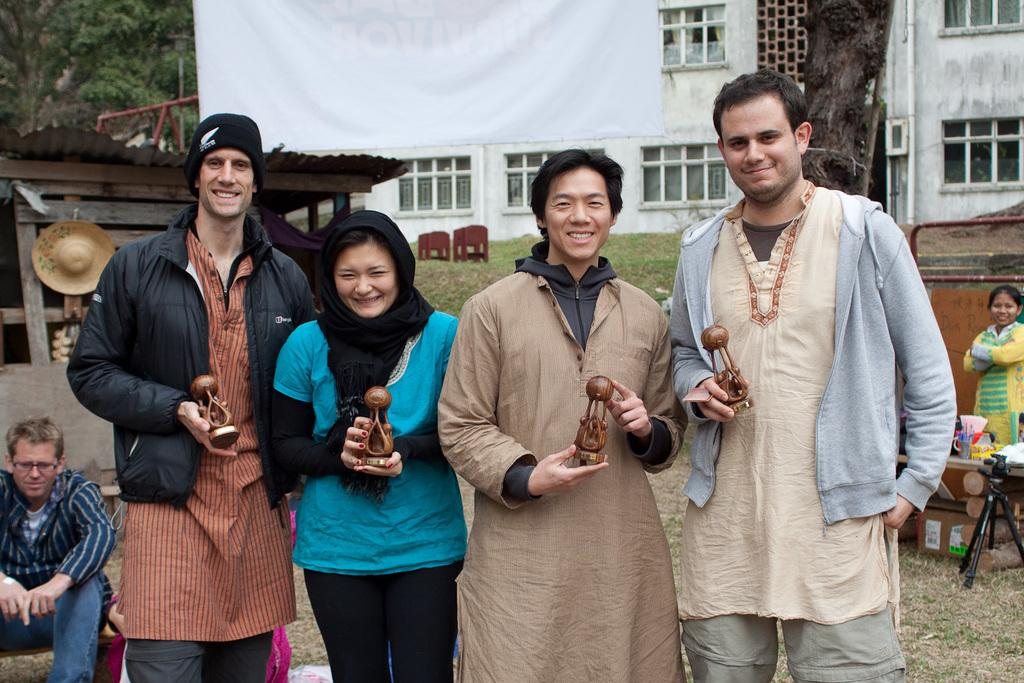How many people are present in the image? There are four persons standing in the image. What are the four persons holding in their hands? Each of the four persons is holding an object in their hands. Can you describe the background of the image? There are people, a building, and trees in the background of the image. What type of screw can be seen in the basket in the image? There is no screw or basket present in the image. Can you describe the feather on the head of one of the persons in the image? There is no feather visible on any of the persons in the image. 